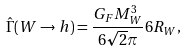<formula> <loc_0><loc_0><loc_500><loc_500>\hat { \Gamma } ( W \to h ) = \frac { G _ { F } M _ { W } ^ { 3 } } { 6 \sqrt { 2 } \pi } 6 R _ { W } ,</formula> 